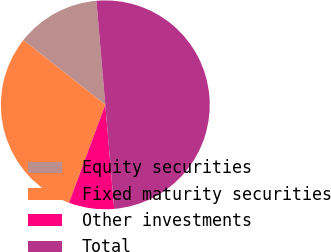Convert chart to OTSL. <chart><loc_0><loc_0><loc_500><loc_500><pie_chart><fcel>Equity securities<fcel>Fixed maturity securities<fcel>Other investments<fcel>Total<nl><fcel>13.0%<fcel>30.0%<fcel>7.0%<fcel>50.0%<nl></chart> 